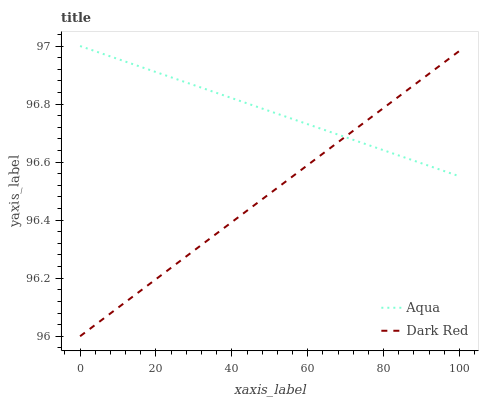Does Dark Red have the minimum area under the curve?
Answer yes or no. Yes. Does Aqua have the maximum area under the curve?
Answer yes or no. Yes. Does Aqua have the minimum area under the curve?
Answer yes or no. No. Is Aqua the smoothest?
Answer yes or no. Yes. Is Dark Red the roughest?
Answer yes or no. Yes. Is Aqua the roughest?
Answer yes or no. No. Does Dark Red have the lowest value?
Answer yes or no. Yes. Does Aqua have the lowest value?
Answer yes or no. No. Does Aqua have the highest value?
Answer yes or no. Yes. Does Dark Red intersect Aqua?
Answer yes or no. Yes. Is Dark Red less than Aqua?
Answer yes or no. No. Is Dark Red greater than Aqua?
Answer yes or no. No. 